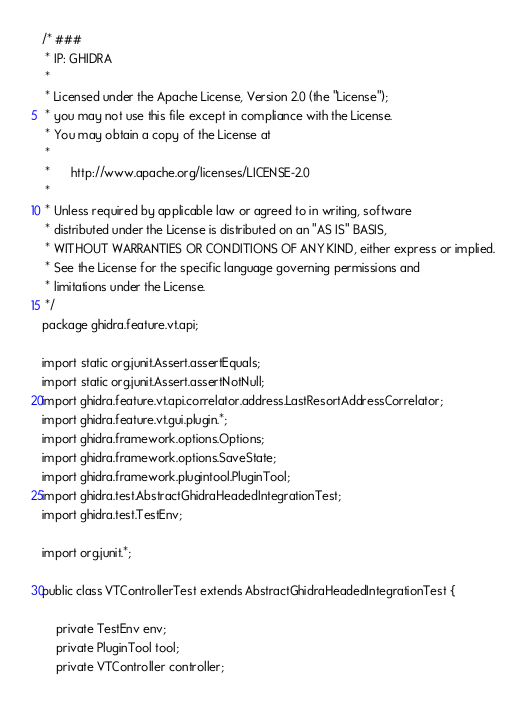<code> <loc_0><loc_0><loc_500><loc_500><_Java_>/* ###
 * IP: GHIDRA
 *
 * Licensed under the Apache License, Version 2.0 (the "License");
 * you may not use this file except in compliance with the License.
 * You may obtain a copy of the License at
 * 
 *      http://www.apache.org/licenses/LICENSE-2.0
 * 
 * Unless required by applicable law or agreed to in writing, software
 * distributed under the License is distributed on an "AS IS" BASIS,
 * WITHOUT WARRANTIES OR CONDITIONS OF ANY KIND, either express or implied.
 * See the License for the specific language governing permissions and
 * limitations under the License.
 */
package ghidra.feature.vt.api;

import static org.junit.Assert.assertEquals;
import static org.junit.Assert.assertNotNull;
import ghidra.feature.vt.api.correlator.address.LastResortAddressCorrelator;
import ghidra.feature.vt.gui.plugin.*;
import ghidra.framework.options.Options;
import ghidra.framework.options.SaveState;
import ghidra.framework.plugintool.PluginTool;
import ghidra.test.AbstractGhidraHeadedIntegrationTest;
import ghidra.test.TestEnv;

import org.junit.*;

public class VTControllerTest extends AbstractGhidraHeadedIntegrationTest {

	private TestEnv env;
	private PluginTool tool;
	private VTController controller;
</code> 